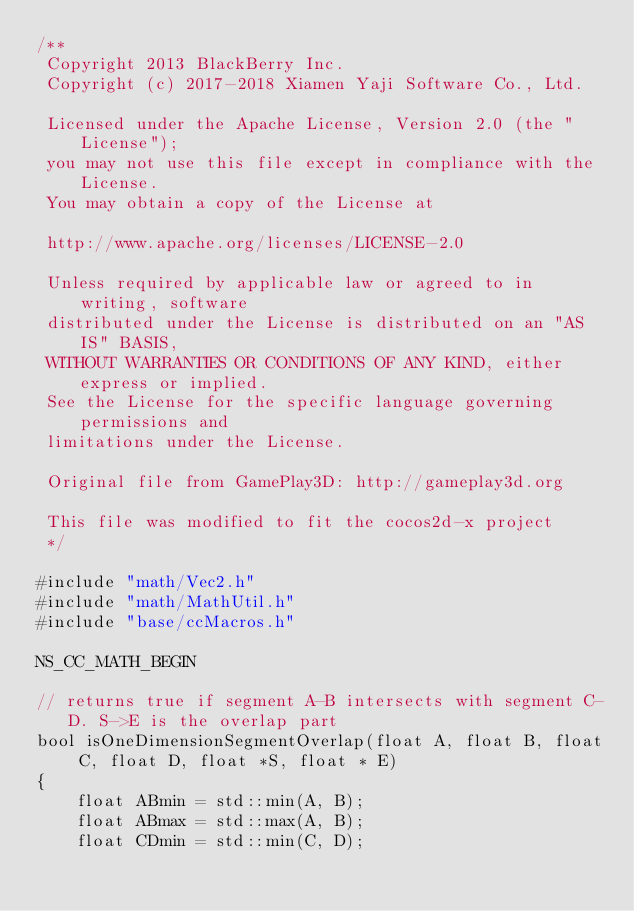<code> <loc_0><loc_0><loc_500><loc_500><_C++_>/**
 Copyright 2013 BlackBerry Inc.
 Copyright (c) 2017-2018 Xiamen Yaji Software Co., Ltd.

 Licensed under the Apache License, Version 2.0 (the "License");
 you may not use this file except in compliance with the License.
 You may obtain a copy of the License at

 http://www.apache.org/licenses/LICENSE-2.0

 Unless required by applicable law or agreed to in writing, software
 distributed under the License is distributed on an "AS IS" BASIS,
 WITHOUT WARRANTIES OR CONDITIONS OF ANY KIND, either express or implied.
 See the License for the specific language governing permissions and
 limitations under the License.

 Original file from GamePlay3D: http://gameplay3d.org

 This file was modified to fit the cocos2d-x project
 */

#include "math/Vec2.h"
#include "math/MathUtil.h"
#include "base/ccMacros.h"

NS_CC_MATH_BEGIN

// returns true if segment A-B intersects with segment C-D. S->E is the overlap part
bool isOneDimensionSegmentOverlap(float A, float B, float C, float D, float *S, float * E)
{
    float ABmin = std::min(A, B);
    float ABmax = std::max(A, B);
    float CDmin = std::min(C, D);</code> 